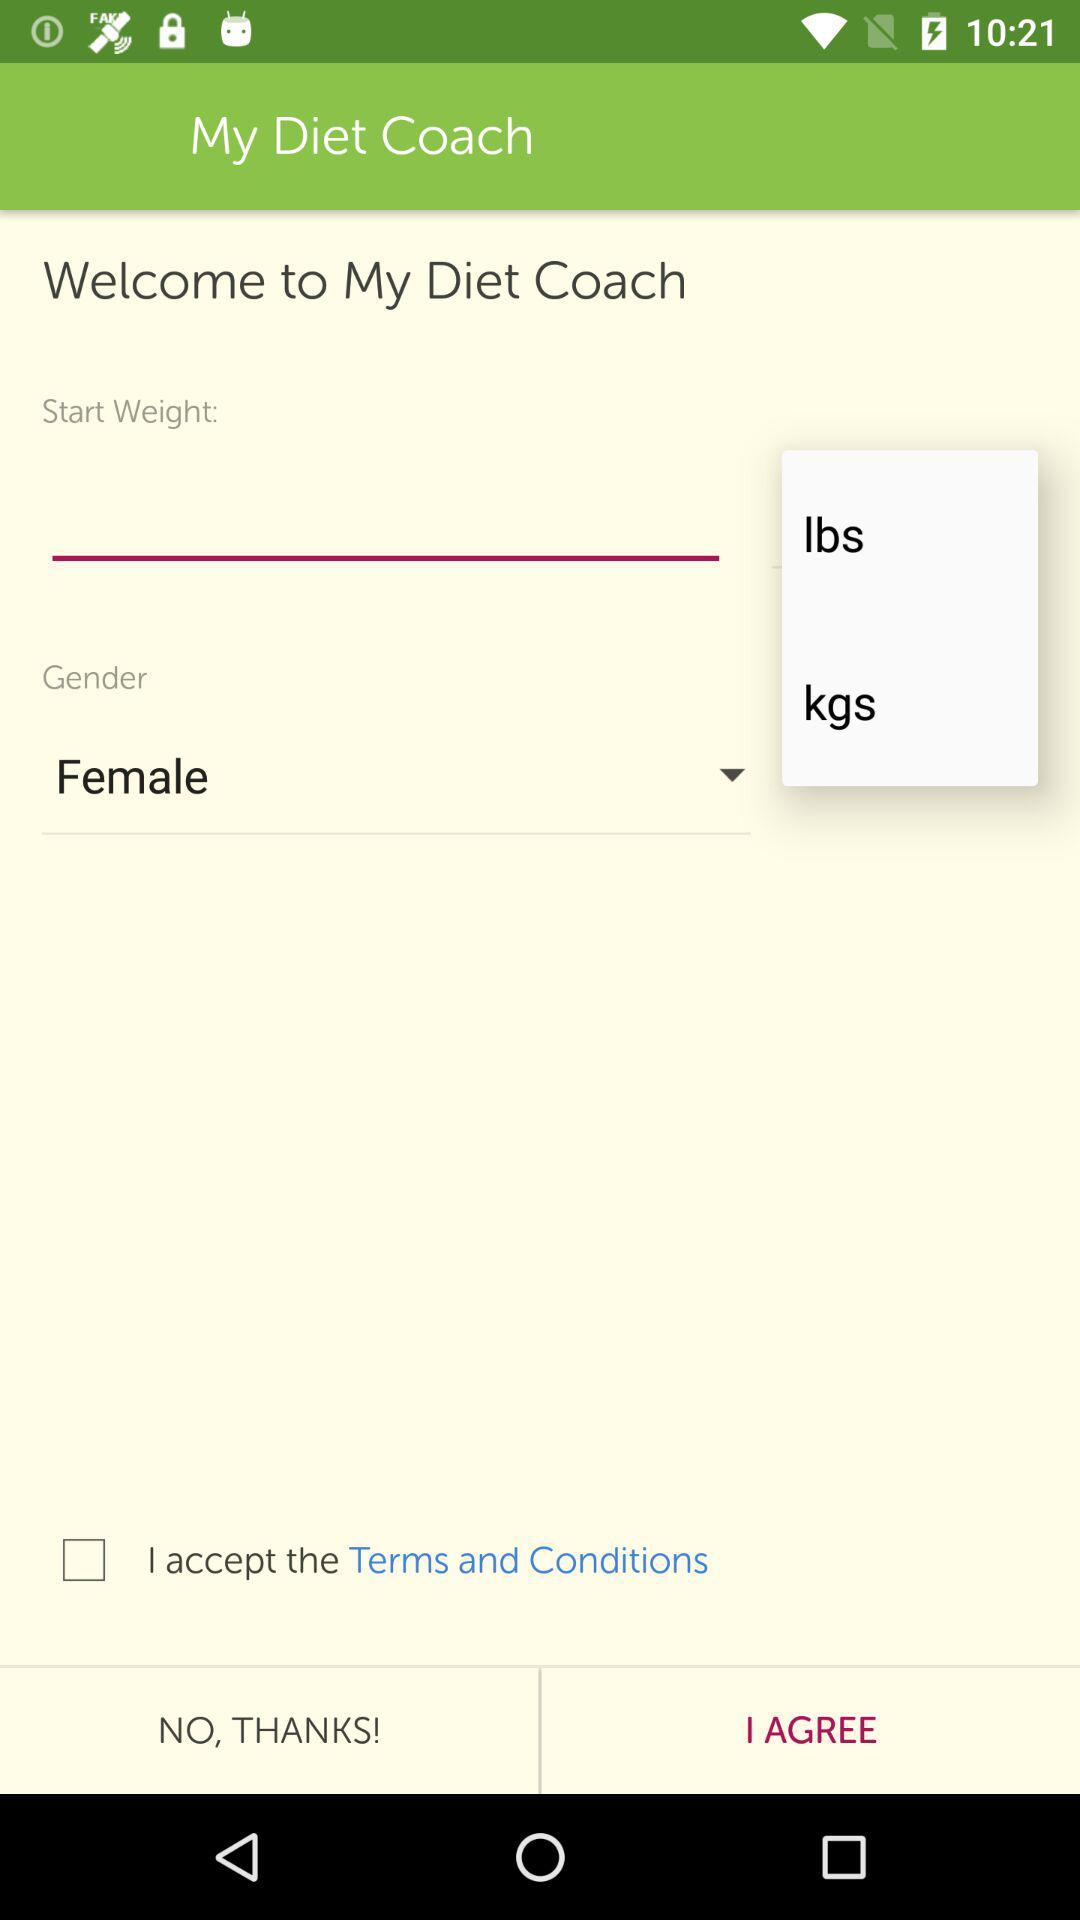What is the status of "I accept the Terms and Conditions"? The status of "I accept the Terms and Conditions" is off. 